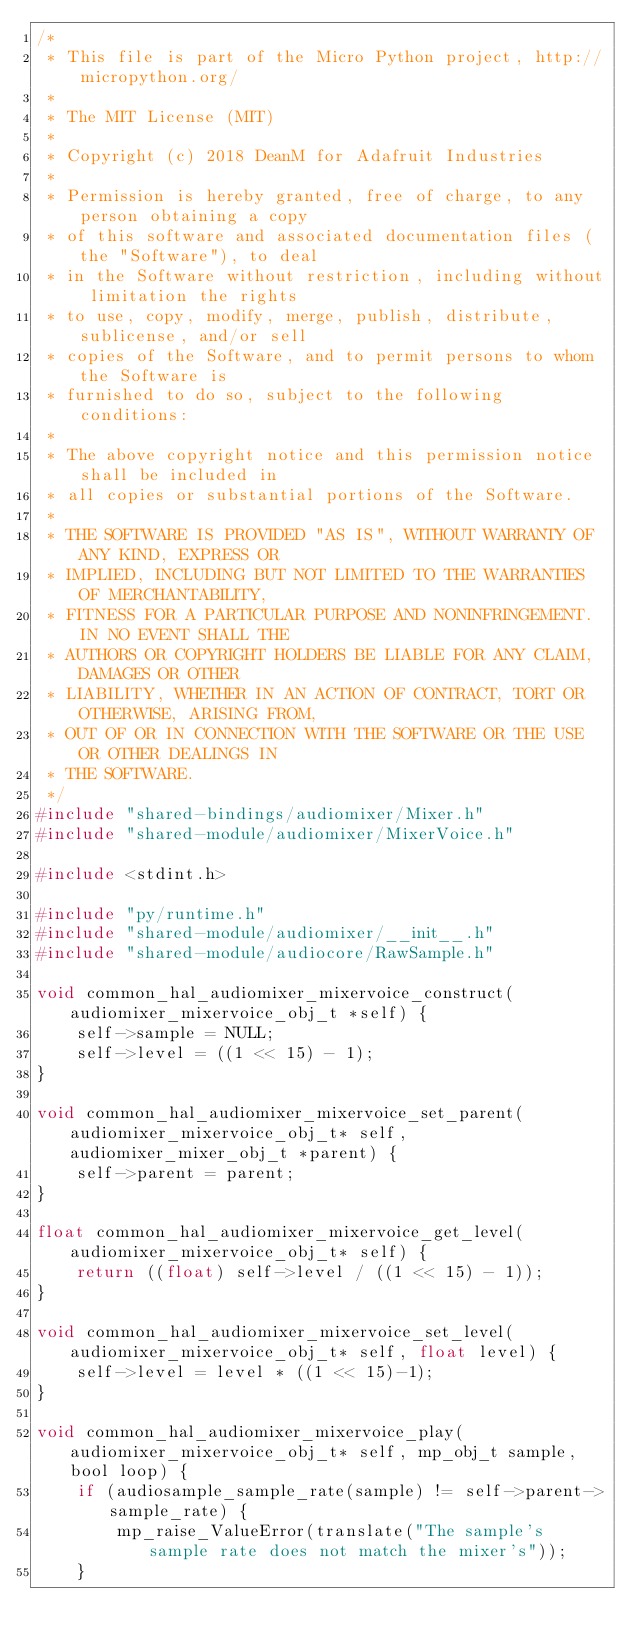<code> <loc_0><loc_0><loc_500><loc_500><_C_>/*
 * This file is part of the Micro Python project, http://micropython.org/
 *
 * The MIT License (MIT)
 *
 * Copyright (c) 2018 DeanM for Adafruit Industries
 *
 * Permission is hereby granted, free of charge, to any person obtaining a copy
 * of this software and associated documentation files (the "Software"), to deal
 * in the Software without restriction, including without limitation the rights
 * to use, copy, modify, merge, publish, distribute, sublicense, and/or sell
 * copies of the Software, and to permit persons to whom the Software is
 * furnished to do so, subject to the following conditions:
 *
 * The above copyright notice and this permission notice shall be included in
 * all copies or substantial portions of the Software.
 *
 * THE SOFTWARE IS PROVIDED "AS IS", WITHOUT WARRANTY OF ANY KIND, EXPRESS OR
 * IMPLIED, INCLUDING BUT NOT LIMITED TO THE WARRANTIES OF MERCHANTABILITY,
 * FITNESS FOR A PARTICULAR PURPOSE AND NONINFRINGEMENT. IN NO EVENT SHALL THE
 * AUTHORS OR COPYRIGHT HOLDERS BE LIABLE FOR ANY CLAIM, DAMAGES OR OTHER
 * LIABILITY, WHETHER IN AN ACTION OF CONTRACT, TORT OR OTHERWISE, ARISING FROM,
 * OUT OF OR IN CONNECTION WITH THE SOFTWARE OR THE USE OR OTHER DEALINGS IN
 * THE SOFTWARE.
 */
#include "shared-bindings/audiomixer/Mixer.h"
#include "shared-module/audiomixer/MixerVoice.h"

#include <stdint.h>

#include "py/runtime.h"
#include "shared-module/audiomixer/__init__.h"
#include "shared-module/audiocore/RawSample.h"

void common_hal_audiomixer_mixervoice_construct(audiomixer_mixervoice_obj_t *self) {
    self->sample = NULL;
    self->level = ((1 << 15) - 1);
}

void common_hal_audiomixer_mixervoice_set_parent(audiomixer_mixervoice_obj_t* self, audiomixer_mixer_obj_t *parent) {
	self->parent = parent;
}

float common_hal_audiomixer_mixervoice_get_level(audiomixer_mixervoice_obj_t* self) {
	return ((float) self->level / ((1 << 15) - 1));
}

void common_hal_audiomixer_mixervoice_set_level(audiomixer_mixervoice_obj_t* self, float level) {
	self->level = level * ((1 << 15)-1);
}

void common_hal_audiomixer_mixervoice_play(audiomixer_mixervoice_obj_t* self, mp_obj_t sample, bool loop) {
    if (audiosample_sample_rate(sample) != self->parent->sample_rate) {
        mp_raise_ValueError(translate("The sample's sample rate does not match the mixer's"));
    }</code> 